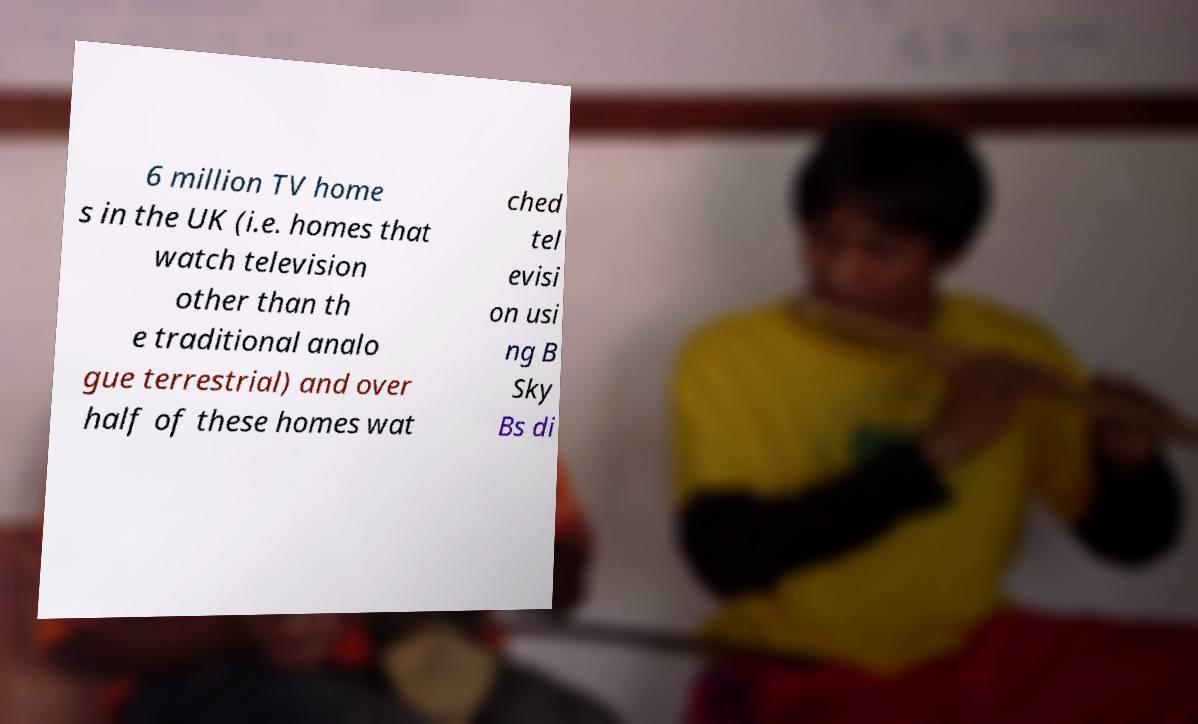Can you read and provide the text displayed in the image?This photo seems to have some interesting text. Can you extract and type it out for me? 6 million TV home s in the UK (i.e. homes that watch television other than th e traditional analo gue terrestrial) and over half of these homes wat ched tel evisi on usi ng B Sky Bs di 